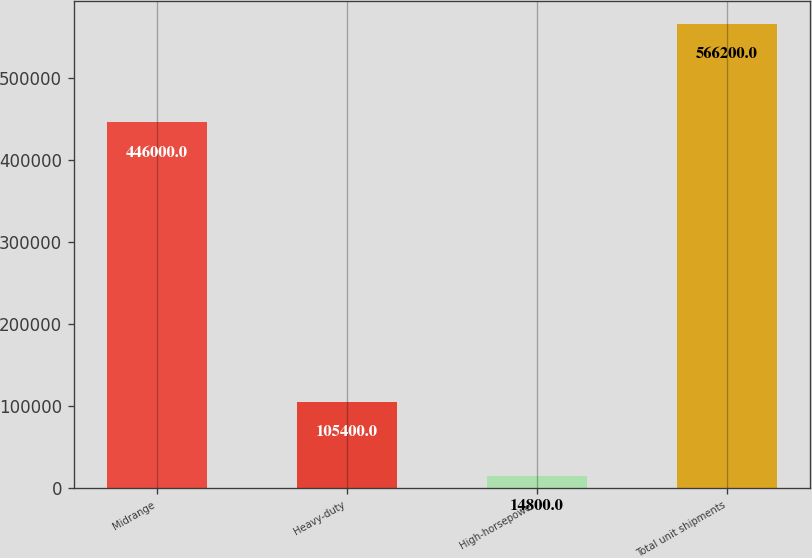Convert chart to OTSL. <chart><loc_0><loc_0><loc_500><loc_500><bar_chart><fcel>Midrange<fcel>Heavy-duty<fcel>High-horsepower<fcel>Total unit shipments<nl><fcel>446000<fcel>105400<fcel>14800<fcel>566200<nl></chart> 